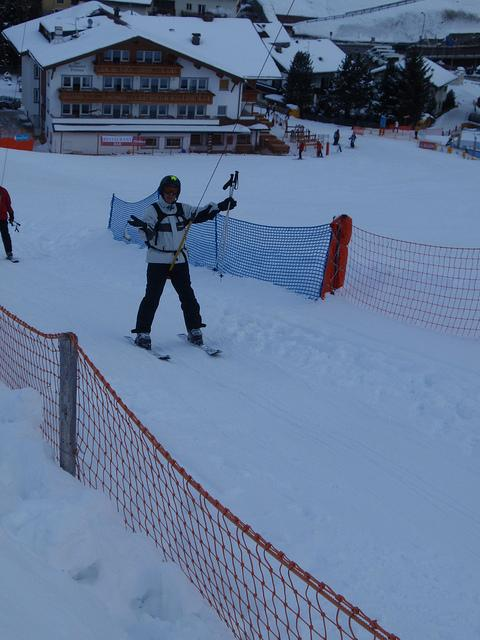What's the name of the large white building in the background? lodge 